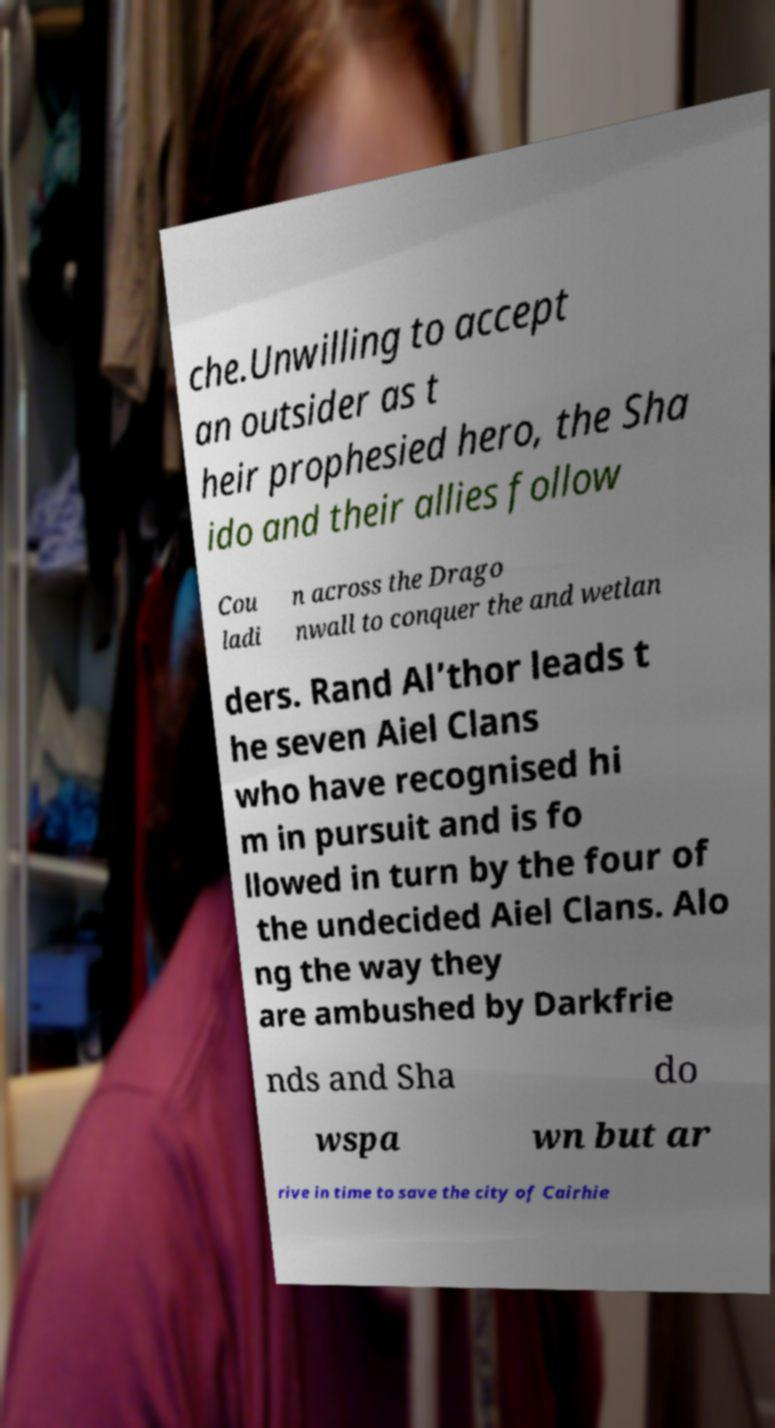What messages or text are displayed in this image? I need them in a readable, typed format. che.Unwilling to accept an outsider as t heir prophesied hero, the Sha ido and their allies follow Cou ladi n across the Drago nwall to conquer the and wetlan ders. Rand Al’thor leads t he seven Aiel Clans who have recognised hi m in pursuit and is fo llowed in turn by the four of the undecided Aiel Clans. Alo ng the way they are ambushed by Darkfrie nds and Sha do wspa wn but ar rive in time to save the city of Cairhie 